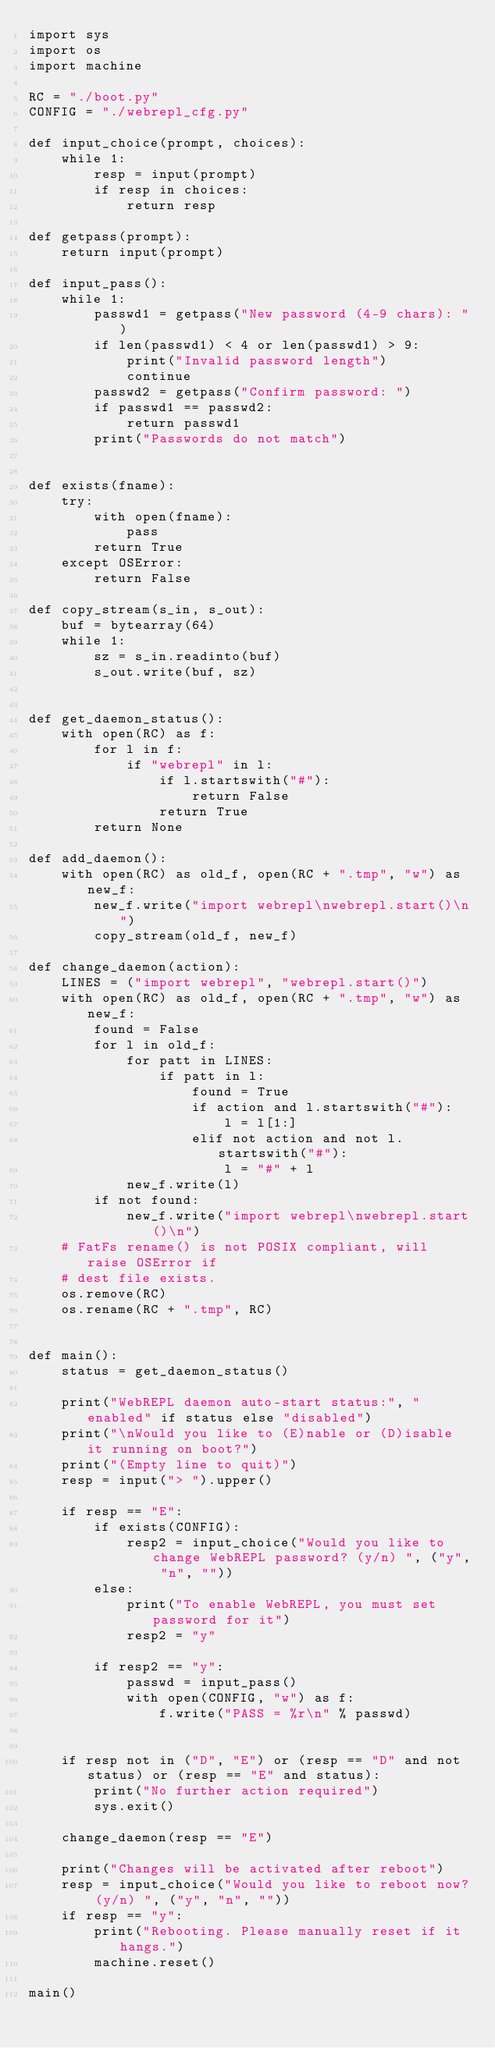Convert code to text. <code><loc_0><loc_0><loc_500><loc_500><_Python_>import sys
import os
import machine

RC = "./boot.py"
CONFIG = "./webrepl_cfg.py"

def input_choice(prompt, choices):
    while 1:
        resp = input(prompt)
        if resp in choices:
            return resp

def getpass(prompt):
    return input(prompt)

def input_pass():
    while 1:
        passwd1 = getpass("New password (4-9 chars): ")
        if len(passwd1) < 4 or len(passwd1) > 9:
            print("Invalid password length")
            continue
        passwd2 = getpass("Confirm password: ")
        if passwd1 == passwd2:
            return passwd1
        print("Passwords do not match")


def exists(fname):
    try:
        with open(fname):
            pass
        return True
    except OSError:
        return False

def copy_stream(s_in, s_out):
    buf = bytearray(64)
    while 1:
        sz = s_in.readinto(buf)
        s_out.write(buf, sz)


def get_daemon_status():
    with open(RC) as f:
        for l in f:
            if "webrepl" in l:
                if l.startswith("#"):
                    return False
                return True
        return None

def add_daemon():
    with open(RC) as old_f, open(RC + ".tmp", "w") as new_f:
        new_f.write("import webrepl\nwebrepl.start()\n")
        copy_stream(old_f, new_f)

def change_daemon(action):
    LINES = ("import webrepl", "webrepl.start()")
    with open(RC) as old_f, open(RC + ".tmp", "w") as new_f:
        found = False
        for l in old_f:
            for patt in LINES:
                if patt in l:
                    found = True
                    if action and l.startswith("#"):
                        l = l[1:]
                    elif not action and not l.startswith("#"):
                        l = "#" + l
            new_f.write(l)
        if not found:
            new_f.write("import webrepl\nwebrepl.start()\n")
    # FatFs rename() is not POSIX compliant, will raise OSError if
    # dest file exists.
    os.remove(RC)
    os.rename(RC + ".tmp", RC)


def main():
    status = get_daemon_status()

    print("WebREPL daemon auto-start status:", "enabled" if status else "disabled")
    print("\nWould you like to (E)nable or (D)isable it running on boot?")
    print("(Empty line to quit)")
    resp = input("> ").upper()

    if resp == "E":
        if exists(CONFIG):
            resp2 = input_choice("Would you like to change WebREPL password? (y/n) ", ("y", "n", ""))
        else:
            print("To enable WebREPL, you must set password for it")
            resp2 = "y"

        if resp2 == "y":
            passwd = input_pass()
            with open(CONFIG, "w") as f:
                f.write("PASS = %r\n" % passwd)


    if resp not in ("D", "E") or (resp == "D" and not status) or (resp == "E" and status):
        print("No further action required")
        sys.exit()

    change_daemon(resp == "E")

    print("Changes will be activated after reboot")
    resp = input_choice("Would you like to reboot now? (y/n) ", ("y", "n", ""))
    if resp == "y":
        print("Rebooting. Please manually reset if it hangs.")
        machine.reset()

main()
</code> 